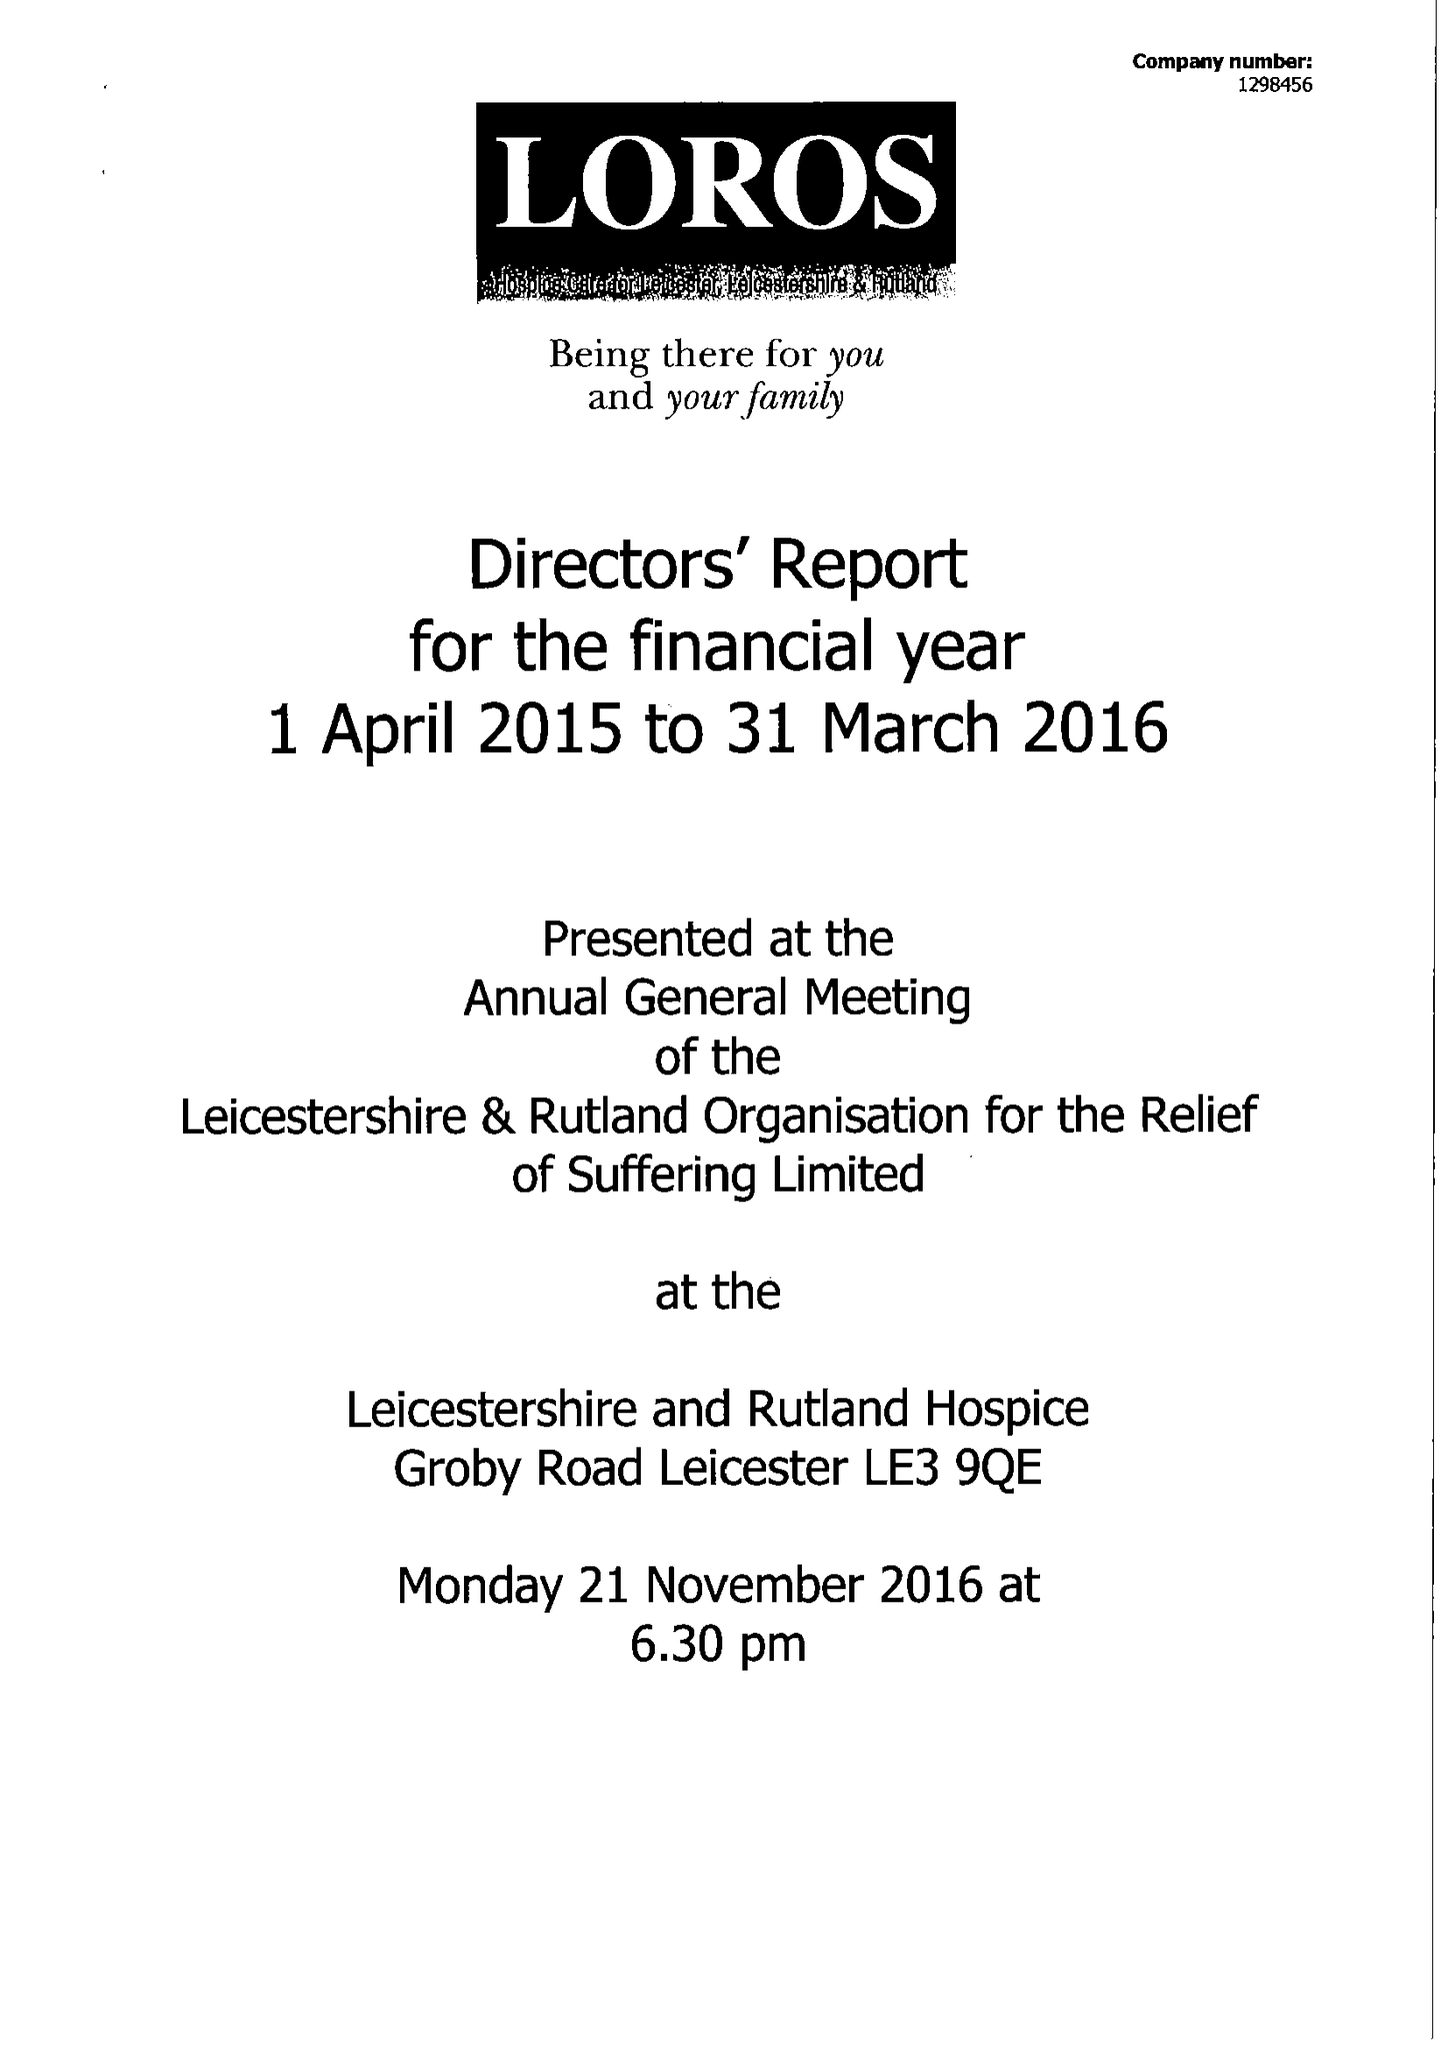What is the value for the income_annually_in_british_pounds?
Answer the question using a single word or phrase. 12786948.00 